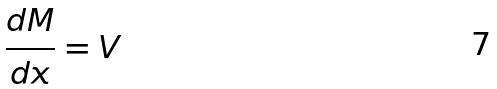Convert formula to latex. <formula><loc_0><loc_0><loc_500><loc_500>\frac { d M } { d x } = V</formula> 